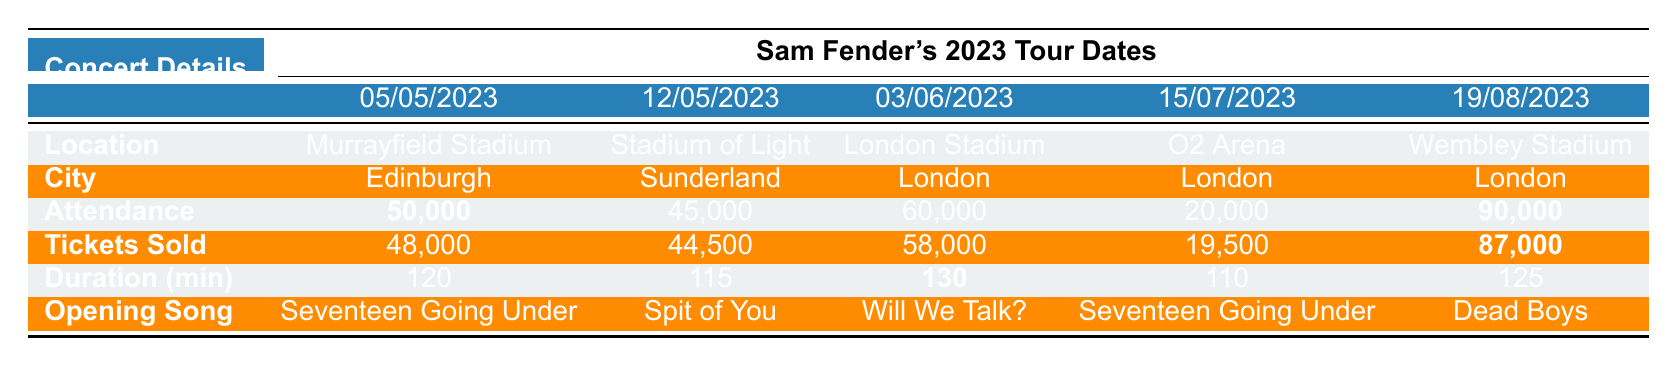What is the highest concert attendance? By looking at the attendance figures in the table, the highest value is marked in bold as 90,000 at Wembley Stadium on August 19, 2023.
Answer: 90,000 Which concert had the longest show duration? The show durations are listed with the longest one highlighted in bold as 130 minutes, which occurs for the concert at London Stadium on June 3, 2023.
Answer: 130 minutes How many tickets were sold at the O2 Arena concert? Referring to the table, the tickets sold at the O2 Arena on July 15, 2023, is noted as 19,500.
Answer: 19,500 What is the average attendance of all concerts? The total attendance can be calculated as 50,000 + 45,000 + 60,000 + 20,000 + 90,000 = 265,000. There are 5 concerts, so the average is 265,000 / 5 = 53,000.
Answer: 53,000 Did any concert exceed a 50,000 attendance? By checking the attendance values, we find that both the Murrayfield Stadium concert (50,000) and the Wembley Stadium concert (90,000) meet this criterion, so yes.
Answer: Yes How much more was the attendance at Wembley Stadium compared to the O2 Arena? The attendance at Wembley Stadium is 90,000 and at O2 Arena is 20,000, thus the difference is 90,000 - 20,000 = 70,000.
Answer: 70,000 Which city had the lowest attendance concert? The attendance figures show that the concert at the O2 Arena in London had the lowest attendance at 20,000.
Answer: London (O2 Arena) What percentage of tickets sold were sold for the concert at the Stadium of Light? For Sunderland's concert, 44,500 tickets sold out of 45,000 attendance. The calculation is (44,500 / 45,000) * 100 = 99.44%.
Answer: 99.44% Which concert featured "Will We Talk?" as the opening song? Referring to the setlist, "Will We Talk?" is the opening song for the concert at London Stadium on June 3, 2023.
Answer: June 3, 2023 (London Stadium) How many concerts took place in London? Checking the locations, there are three concerts listed in London: at the London Stadium (June 3), O2 Arena (July 15), and Wembley Stadium (August 19).
Answer: 3 